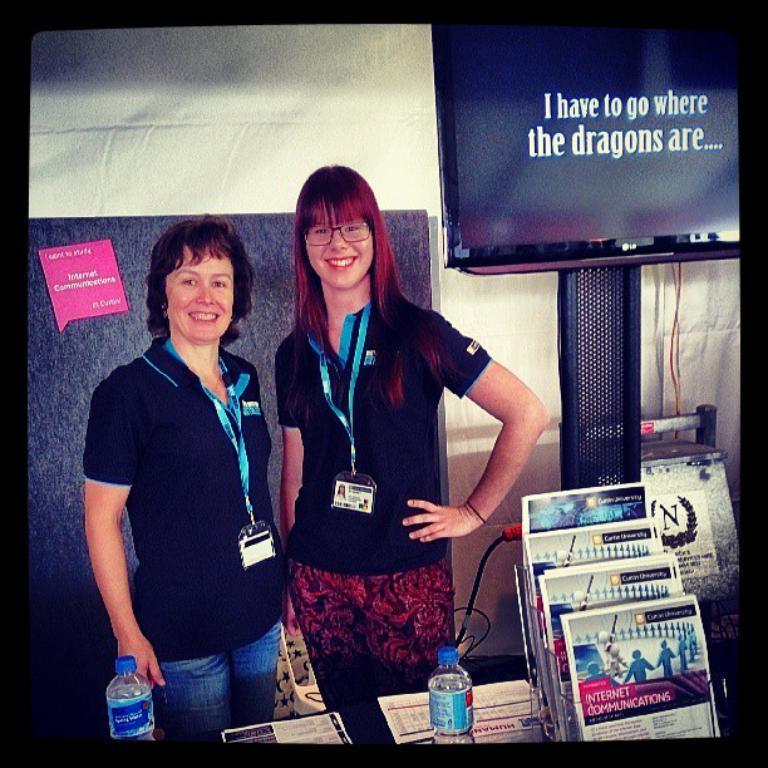Can you describe this image briefly? There are two women standing and wearing tags. In front of them there is a platform with bottles, papers. Also there is a stand with books. In the back there is a television on a stand. In the background there is a wall. 